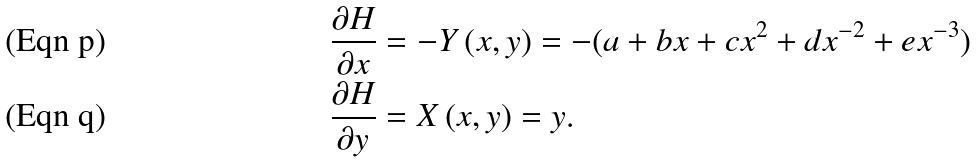Convert formula to latex. <formula><loc_0><loc_0><loc_500><loc_500>\frac { \partial H } { \partial x } & = - Y \left ( x , y \right ) = - ( a + b x + c x ^ { 2 } + d x ^ { - 2 } + e x ^ { - 3 } ) \\ \frac { \partial H } { \partial y } & = X \left ( x , y \right ) = y .</formula> 